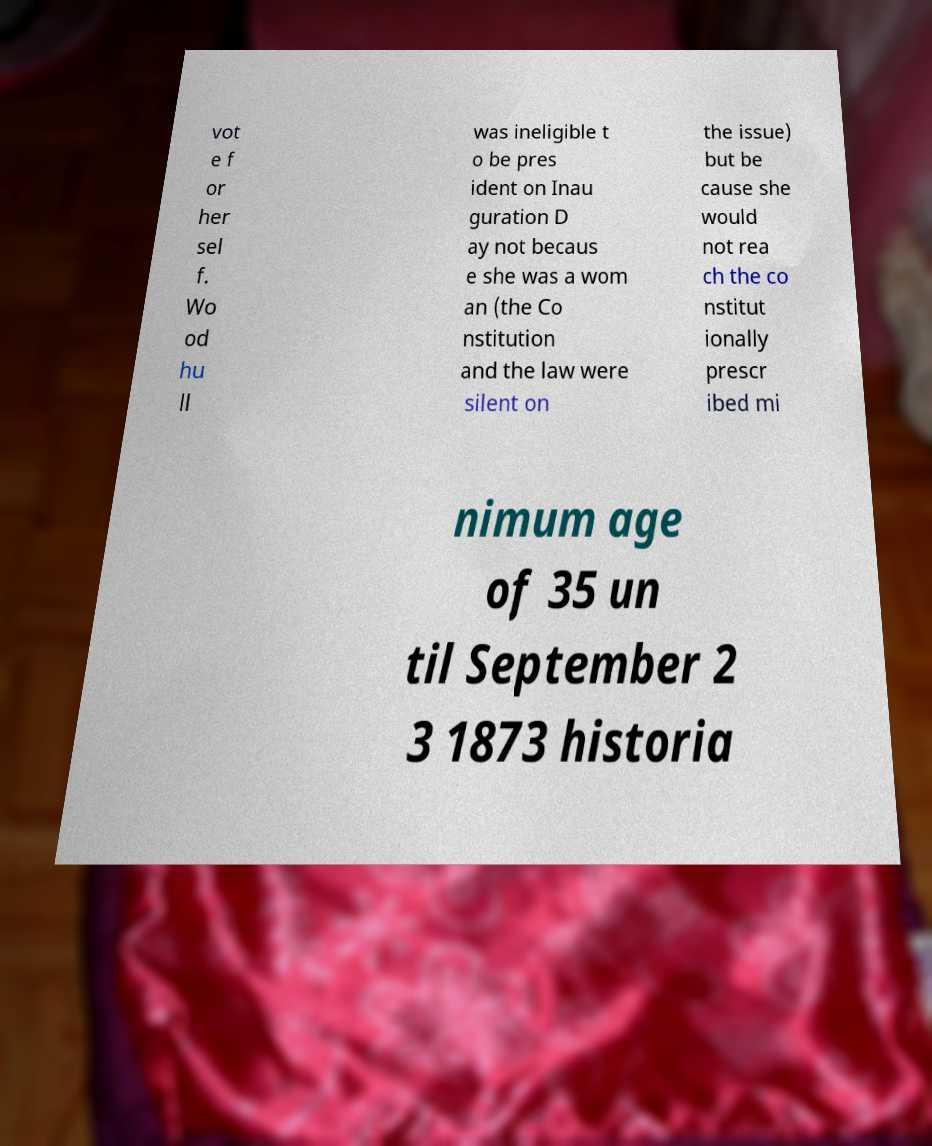There's text embedded in this image that I need extracted. Can you transcribe it verbatim? vot e f or her sel f. Wo od hu ll was ineligible t o be pres ident on Inau guration D ay not becaus e she was a wom an (the Co nstitution and the law were silent on the issue) but be cause she would not rea ch the co nstitut ionally prescr ibed mi nimum age of 35 un til September 2 3 1873 historia 